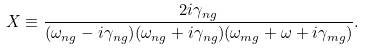Convert formula to latex. <formula><loc_0><loc_0><loc_500><loc_500>X \equiv \frac { 2 i \gamma _ { n g } } { { ( \omega _ { n g } - i \gamma _ { n g } ) } { ( \omega _ { n g } + i \gamma _ { n g } ) } { ( \omega _ { m g } + \omega + i \gamma _ { m g } ) } } .</formula> 